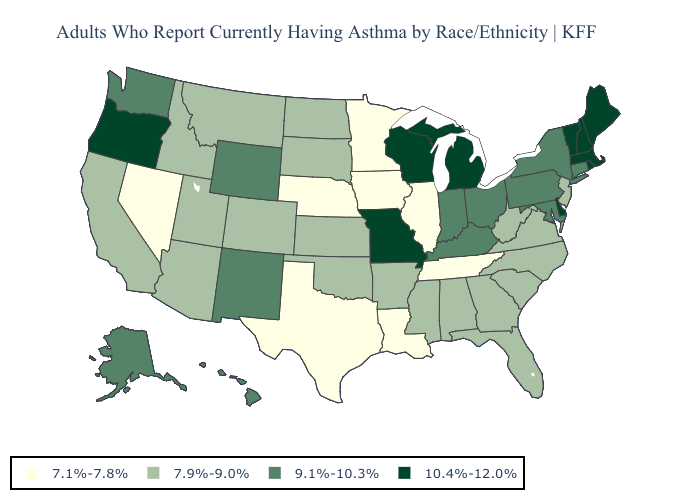Name the states that have a value in the range 9.1%-10.3%?
Concise answer only. Alaska, Connecticut, Hawaii, Indiana, Kentucky, Maryland, New Mexico, New York, Ohio, Pennsylvania, Washington, Wyoming. Name the states that have a value in the range 9.1%-10.3%?
Give a very brief answer. Alaska, Connecticut, Hawaii, Indiana, Kentucky, Maryland, New Mexico, New York, Ohio, Pennsylvania, Washington, Wyoming. How many symbols are there in the legend?
Quick response, please. 4. Among the states that border Tennessee , does Arkansas have the highest value?
Be succinct. No. What is the value of Virginia?
Write a very short answer. 7.9%-9.0%. What is the highest value in the Northeast ?
Keep it brief. 10.4%-12.0%. What is the lowest value in states that border California?
Quick response, please. 7.1%-7.8%. What is the value of Kansas?
Concise answer only. 7.9%-9.0%. What is the lowest value in the USA?
Give a very brief answer. 7.1%-7.8%. Name the states that have a value in the range 10.4%-12.0%?
Short answer required. Delaware, Maine, Massachusetts, Michigan, Missouri, New Hampshire, Oregon, Rhode Island, Vermont, Wisconsin. What is the value of Texas?
Give a very brief answer. 7.1%-7.8%. Name the states that have a value in the range 10.4%-12.0%?
Short answer required. Delaware, Maine, Massachusetts, Michigan, Missouri, New Hampshire, Oregon, Rhode Island, Vermont, Wisconsin. Does Georgia have a higher value than Nevada?
Answer briefly. Yes. What is the highest value in states that border West Virginia?
Be succinct. 9.1%-10.3%. Name the states that have a value in the range 10.4%-12.0%?
Quick response, please. Delaware, Maine, Massachusetts, Michigan, Missouri, New Hampshire, Oregon, Rhode Island, Vermont, Wisconsin. 